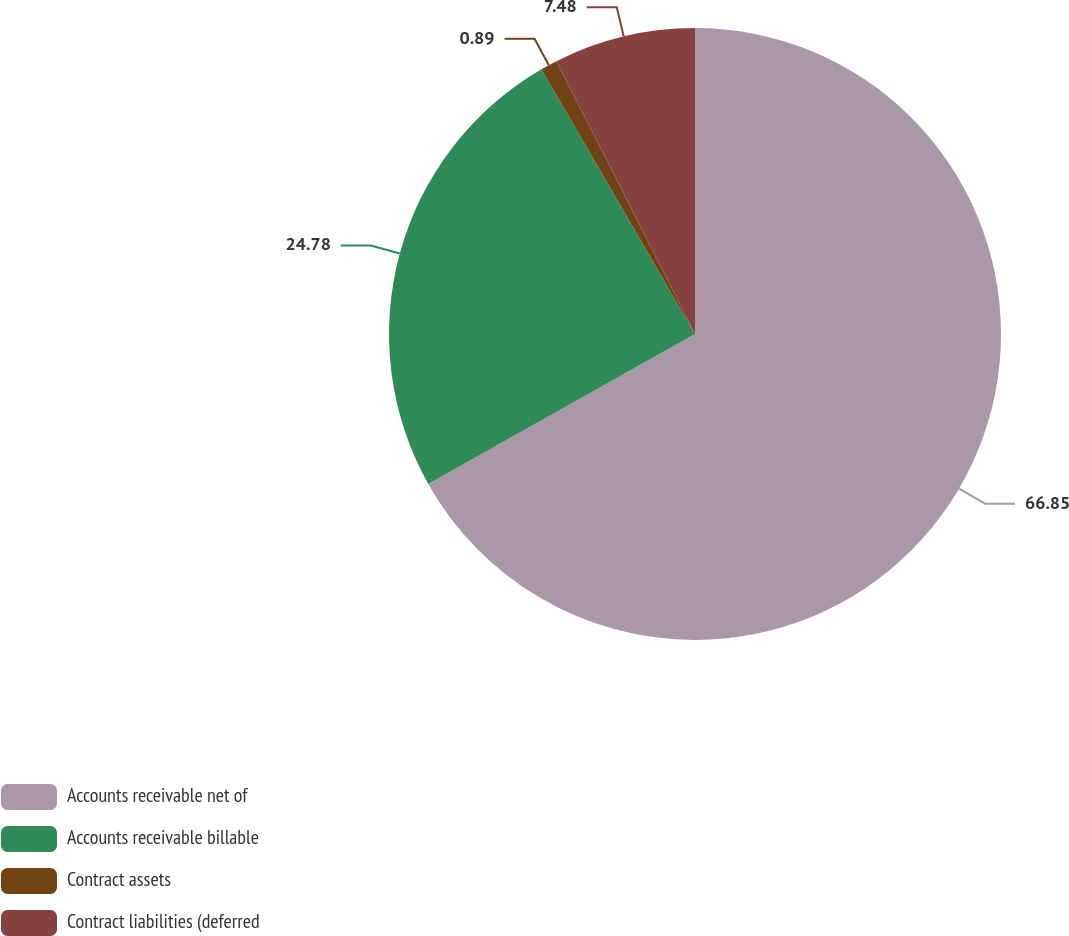Convert chart to OTSL. <chart><loc_0><loc_0><loc_500><loc_500><pie_chart><fcel>Accounts receivable net of<fcel>Accounts receivable billable<fcel>Contract assets<fcel>Contract liabilities (deferred<nl><fcel>66.85%<fcel>24.78%<fcel>0.89%<fcel>7.48%<nl></chart> 